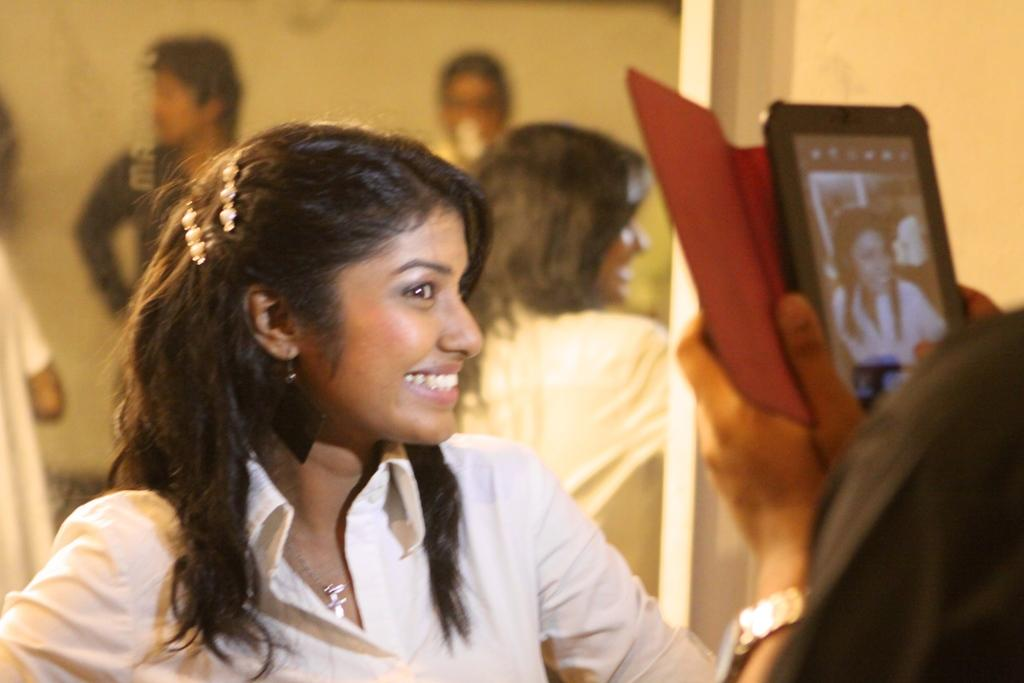Who is the main subject in the picture? There is a girl in the picture. What is the girl doing in the image? The girl is sitting in front of a mirror. Can you describe the person holding a camera in the image? The person is taking a picture. What type of thunder can be heard in the image? There is no thunder present in the image, as it is a still photograph. Is the girl sleeping in the image? The girl is not sleeping in the image; she is sitting in front of a mirror. 